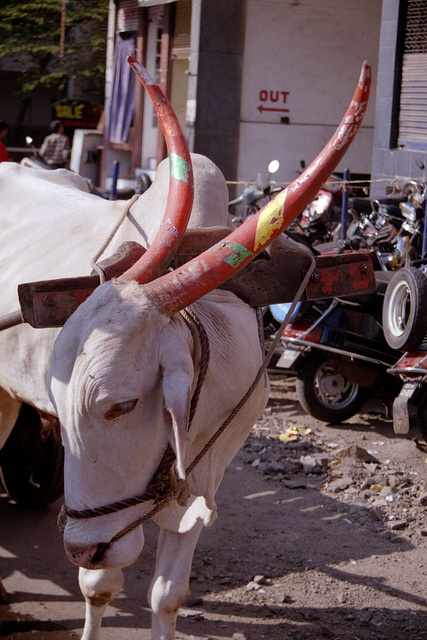Describe the objects in this image and their specific colors. I can see cow in black, gray, lightgray, maroon, and darkgray tones, motorcycle in black, gray, maroon, and darkgray tones, motorcycle in black, gray, maroon, and lavender tones, motorcycle in black, gray, maroon, and darkgray tones, and motorcycle in black, gray, darkgray, and maroon tones in this image. 